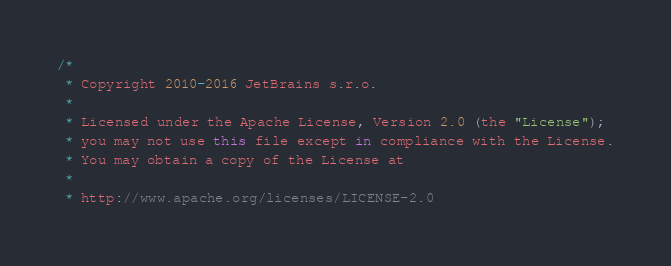<code> <loc_0><loc_0><loc_500><loc_500><_Kotlin_>/*
 * Copyright 2010-2016 JetBrains s.r.o.
 *
 * Licensed under the Apache License, Version 2.0 (the "License");
 * you may not use this file except in compliance with the License.
 * You may obtain a copy of the License at
 *
 * http://www.apache.org/licenses/LICENSE-2.0</code> 